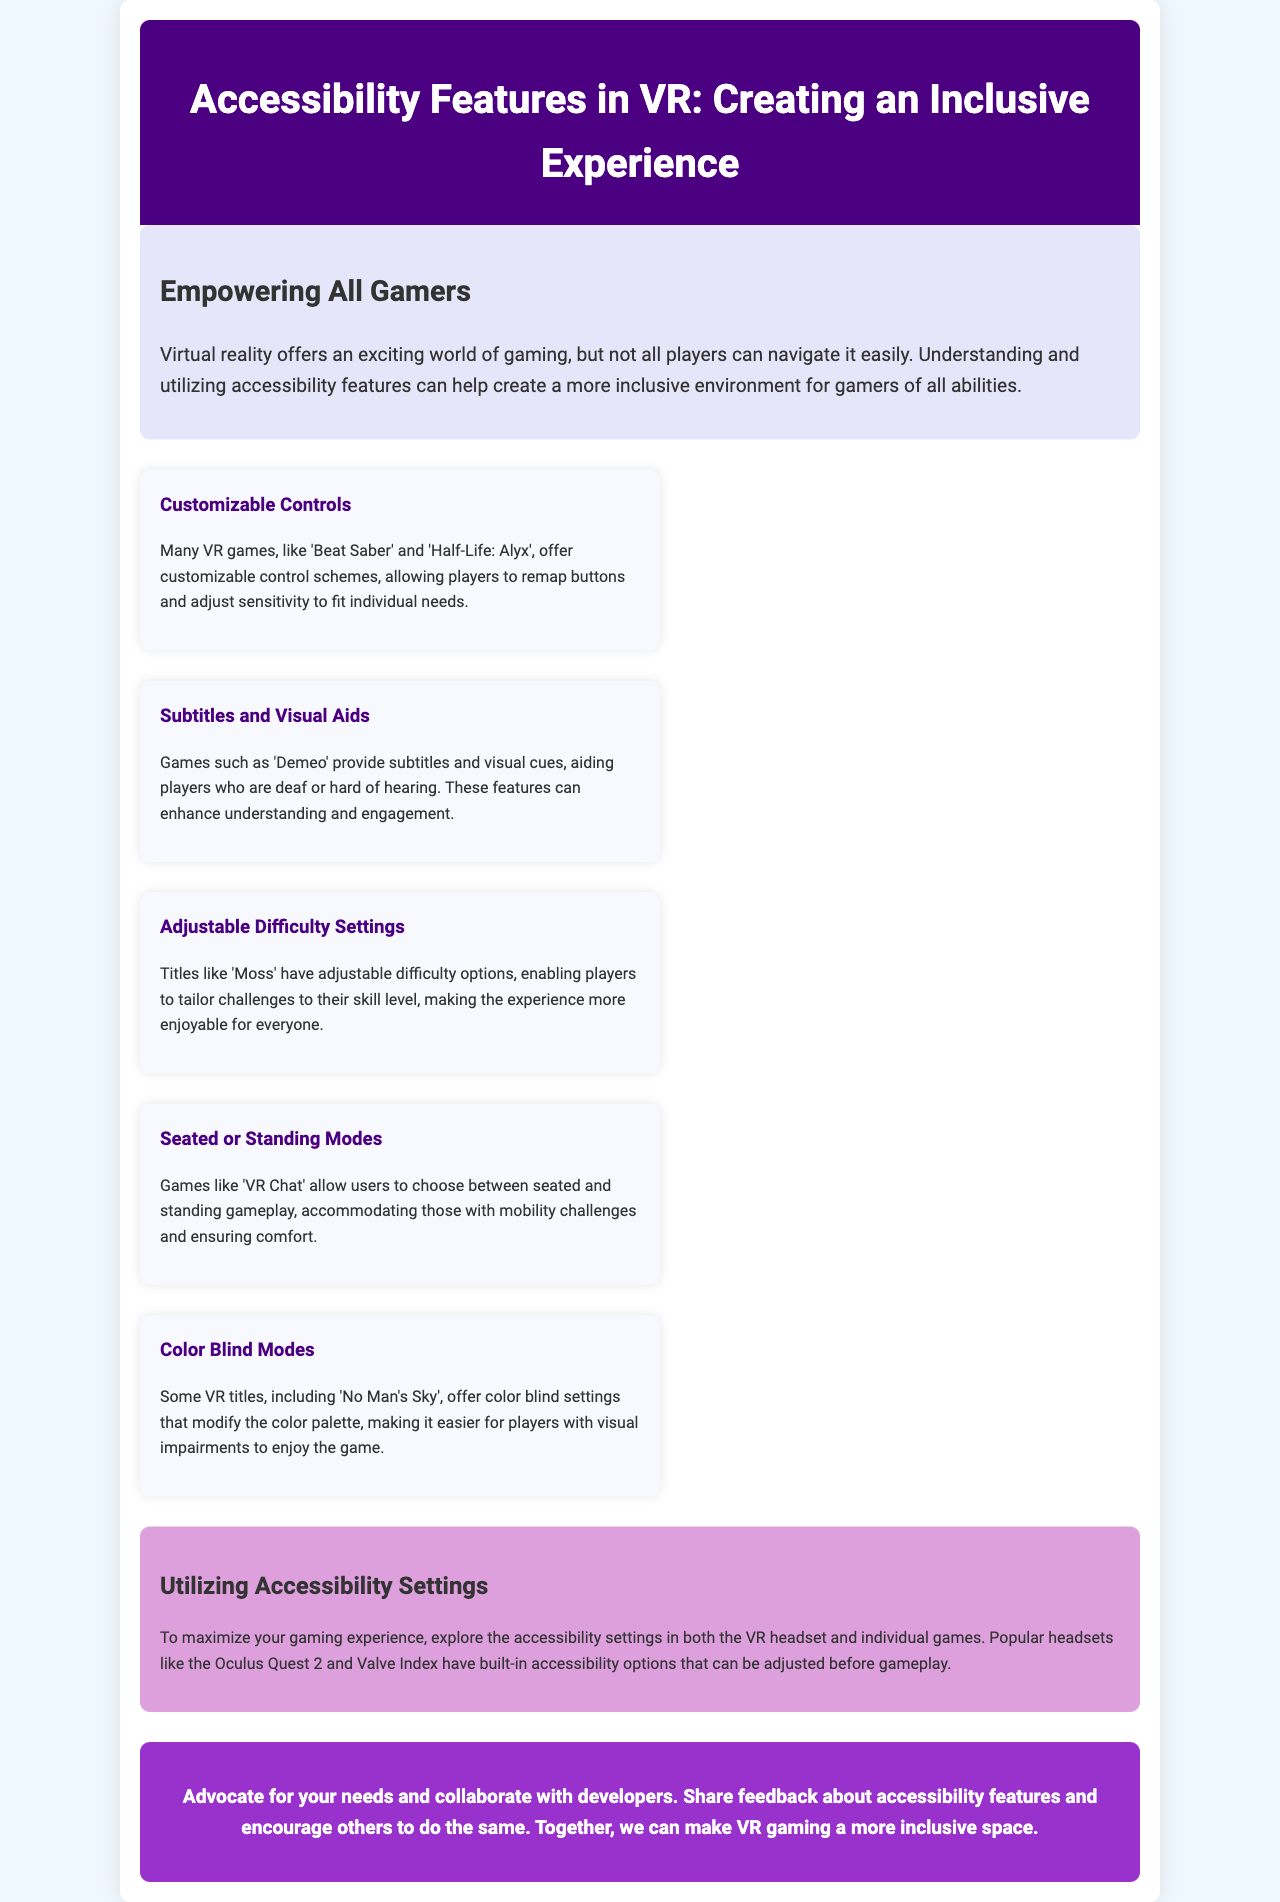What is the title of the brochure? The title is the heading of the document that summarizes the main topic.
Answer: Accessibility Features in VR: Creating an Inclusive Experience What is one of the customizable controls in VR games? The document provides examples of customizable controls in specific games.
Answer: Remap buttons Which game provides subtitles and visual aids? The document lists specific games that offer features for accessibility.
Answer: Demeo What can players adjust in games like 'Moss'? The document indicates features in games that help customize the gaming experience.
Answer: Difficulty settings Which mode does 'VR Chat' offer? The document mentions gameplay modes that cater to different player needs.
Answer: Seated or standing modes What color blind mode game is mentioned? The document refers to specific VR titles that include accessibility options for visual impairments.
Answer: No Man's Sky What type of options do Oculus Quest 2 and Valve Index have? The document emphasizes the importance of certain features in popular VR headsets.
Answer: Built-in accessibility options What is the call to action in the brochure? The last section of the document encourages readers to take a certain action related to accessibility.
Answer: Advocate for your needs How are accessibility features important for gamers? The introduction discusses the significance of these features for various players.
Answer: Create an inclusive environment 